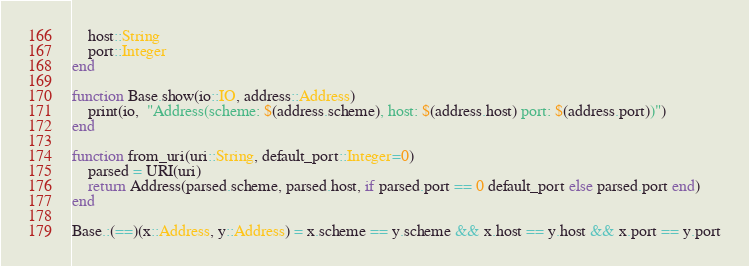Convert code to text. <code><loc_0><loc_0><loc_500><loc_500><_Julia_>    host::String
    port::Integer
end

function Base.show(io::IO, address::Address)
    print(io,  "Address(scheme: $(address.scheme), host: $(address.host) port: $(address.port))")
end

function from_uri(uri::String, default_port::Integer=0)
    parsed = URI(uri)
    return Address(parsed.scheme, parsed.host, if parsed.port == 0 default_port else parsed.port end)
end

Base.:(==)(x::Address, y::Address) = x.scheme == y.scheme && x.host == y.host && x.port == y.port</code> 